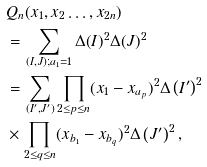<formula> <loc_0><loc_0><loc_500><loc_500>& Q _ { n } ( x _ { 1 } , x _ { 2 } \dots , x _ { 2 n } ) \\ & = \sum _ { ( I , J ) ; a _ { 1 } = 1 } \Delta ( I ) ^ { 2 } \Delta ( J ) ^ { 2 } \\ & = \sum _ { ( I ^ { \prime } , J ^ { \prime } ) } \prod _ { 2 \leq p \leq n } ( x _ { 1 } - x _ { a _ { p } } ) ^ { 2 } \Delta \left ( I ^ { \prime } \right ) ^ { 2 } \\ & \times \prod _ { 2 \leq q \leq n } ( x _ { b _ { 1 } } - x _ { b _ { q } } ) ^ { 2 } \Delta \left ( J ^ { \prime } \right ) ^ { 2 } ,</formula> 